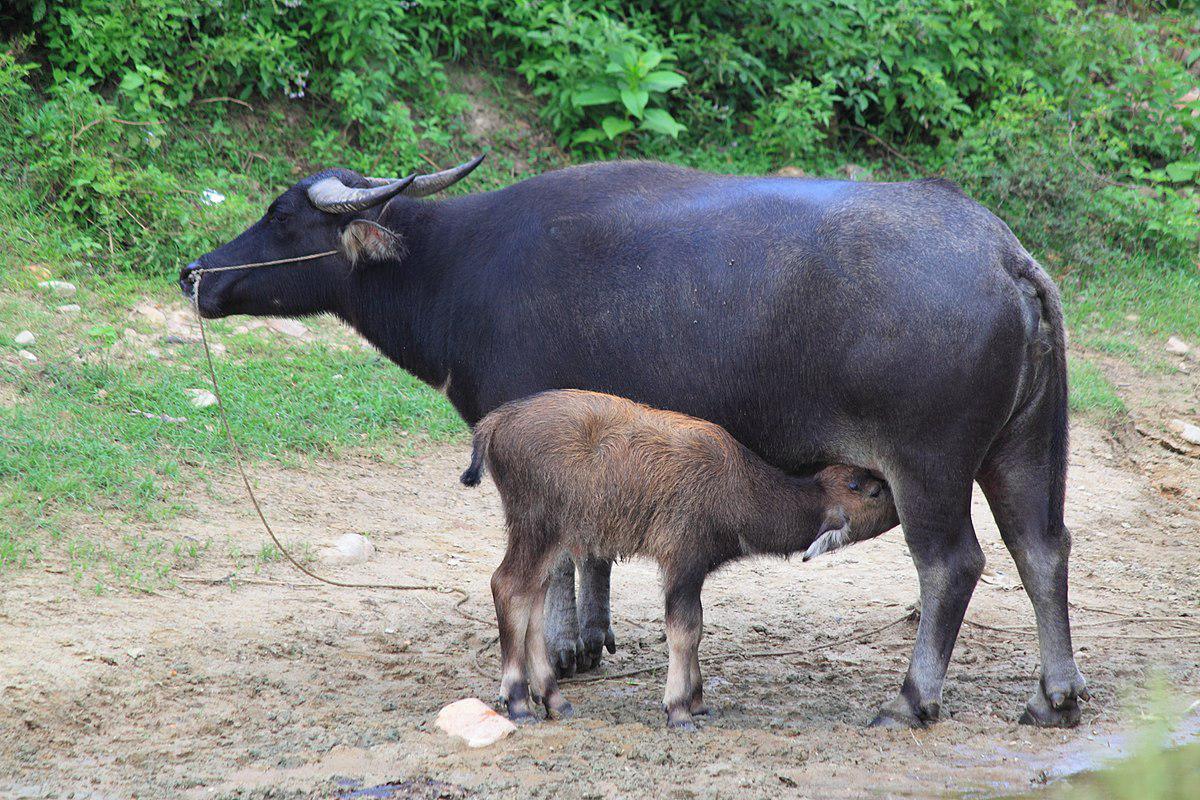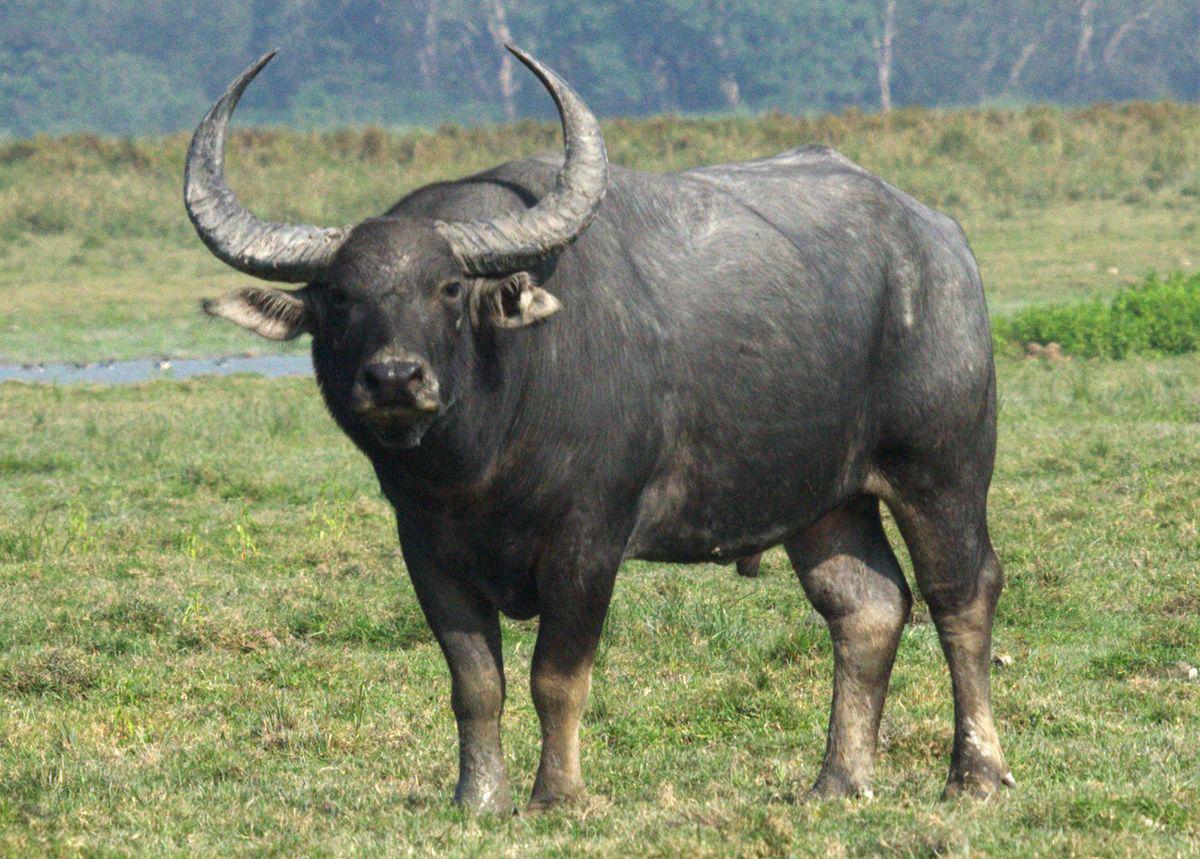The first image is the image on the left, the second image is the image on the right. For the images shown, is this caption "There are two bison-like creatures only." true? Answer yes or no. No. 